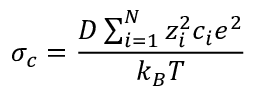Convert formula to latex. <formula><loc_0><loc_0><loc_500><loc_500>\sigma _ { c } = \frac { D \sum _ { i = 1 } ^ { N } z _ { i } ^ { 2 } c _ { i } e ^ { 2 } } { k _ { B } T }</formula> 